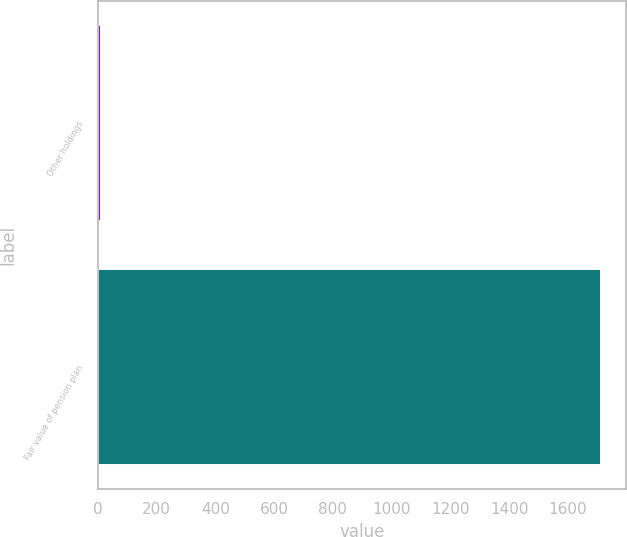<chart> <loc_0><loc_0><loc_500><loc_500><bar_chart><fcel>Other holdings<fcel>Fair value of pension plan<nl><fcel>11<fcel>1714<nl></chart> 